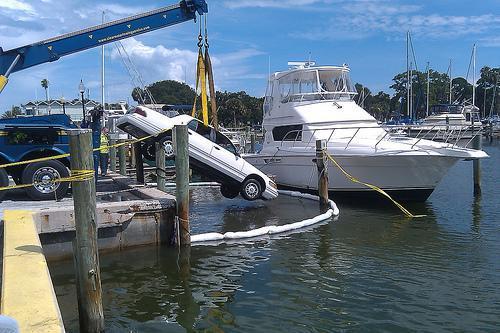How many cars?
Give a very brief answer. 1. 